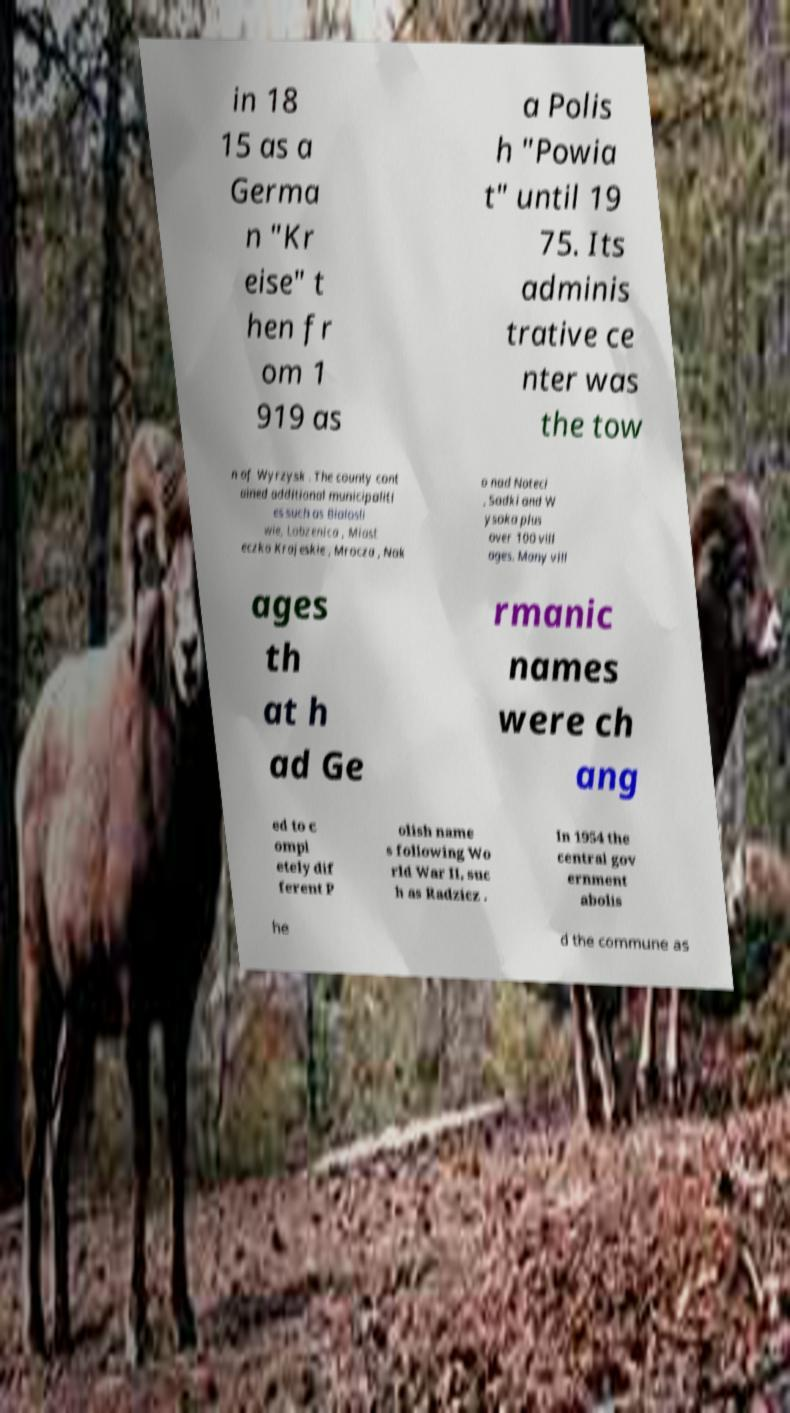Can you accurately transcribe the text from the provided image for me? in 18 15 as a Germa n "Kr eise" t hen fr om 1 919 as a Polis h "Powia t" until 19 75. Its adminis trative ce nter was the tow n of Wyrzysk . The county cont ained additional municipaliti es such as Bialosli wie, Lobzenica , Miast eczko Krajeskie , Mrocza , Nak o nad Noteci , Sadki and W ysoka plus over 100 vill ages. Many vill ages th at h ad Ge rmanic names were ch ang ed to c ompl etely dif ferent P olish name s following Wo rld War II, suc h as Radzicz . In 1954 the central gov ernment abolis he d the commune as 